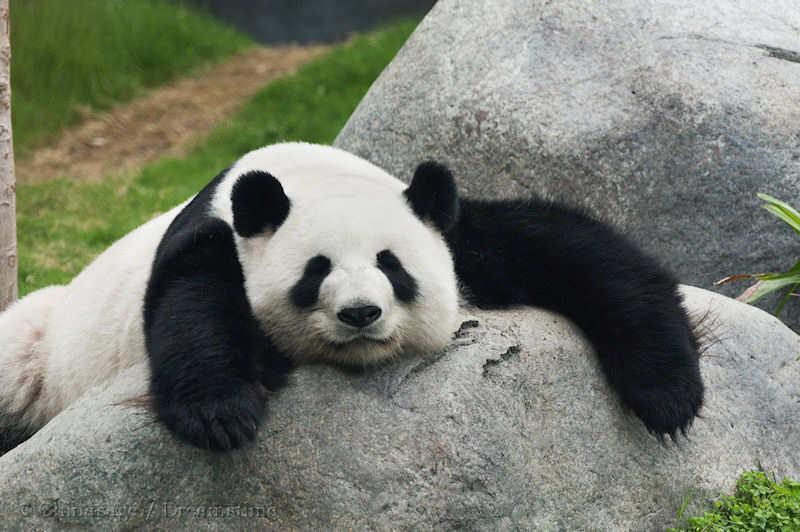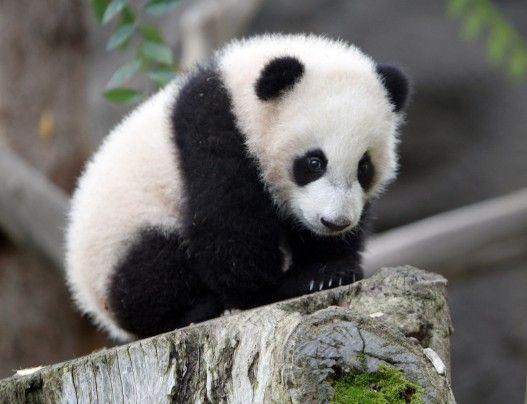The first image is the image on the left, the second image is the image on the right. Assess this claim about the two images: "there are at most 2 pandas in the image pair". Correct or not? Answer yes or no. Yes. The first image is the image on the left, the second image is the image on the right. Analyze the images presented: Is the assertion "There are three pandas" valid? Answer yes or no. No. 